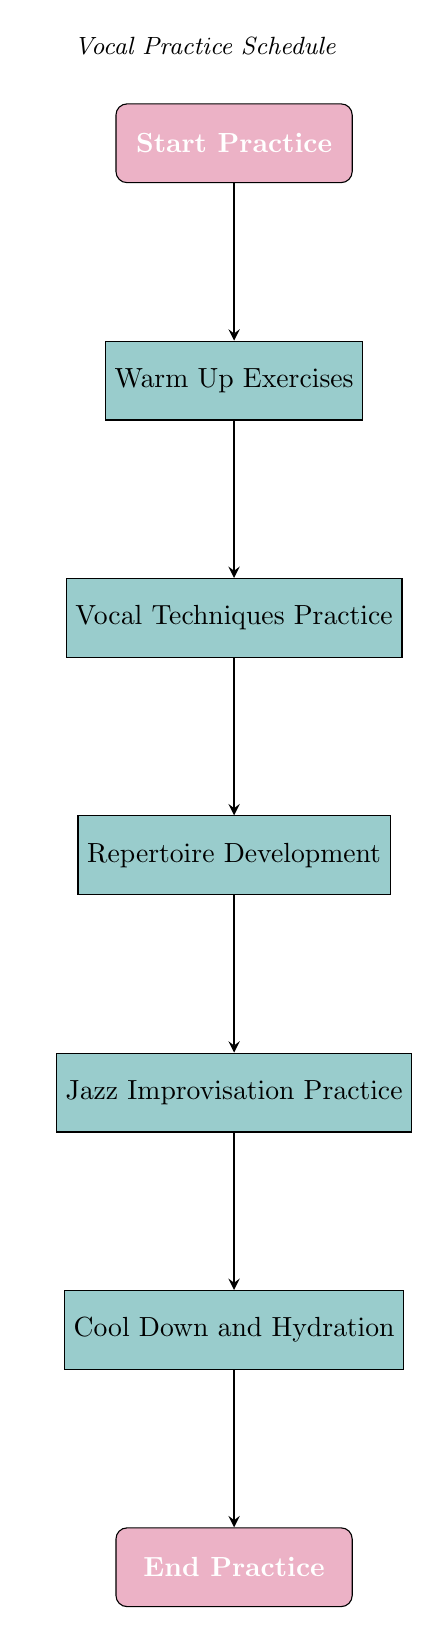What's the first step in the vocal practice schedule? The first node in the diagram is labeled "Start Practice," indicating that this is the initial step in the workflow.
Answer: Start Practice How many nodes are present in the diagram? By counting the nodes listed in the data section, there are a total of 7 nodes, which contribute to the structure of the flow chart.
Answer: 7 What follows after the Warm Up Exercises? The next node after "Warm Up Exercises" is "Vocal Techniques Practice," as indicated by the directed edge connecting these two nodes.
Answer: Vocal Techniques Practice Which step comes before the Jazz Improvisation Practice? The step immediately preceding "Jazz Improvisation Practice" in the flow chart is "Repertoire Development," which shows the workflow of the practice schedule.
Answer: Repertoire Development What is the last step in the vocal practice schedule? The last node in the diagram, reached after following all previous steps, is labeled "End Practice," signifying that this concludes the practice session.
Answer: End Practice What is the relationship between Vocal Techniques Practice and Repertoire Development? The diagram shows a directed edge leading from "Vocal Techniques Practice" to "Repertoire Development," indicating a sequential flow from one practice aspect to the next.
Answer: Sequential flow How many edges are there in this diagram? By counting the connections (edges) between nodes, there are a total of 6 edges that follow the flow from start to finish in the practice schedule.
Answer: 6 What is the process immediately after Cool Down and Hydration? Following "Cool Down and Hydration," the flow chart indicates that the next step is "End Practice," which represents the conclusion of the practice activities.
Answer: End Practice Which practice step allows for creative expression? The step labeled "Jazz Improvisation Practice" is specifically aimed at enhancing creative expression through improvisation techniques unique to jazz vocals.
Answer: Jazz Improvisation Practice 